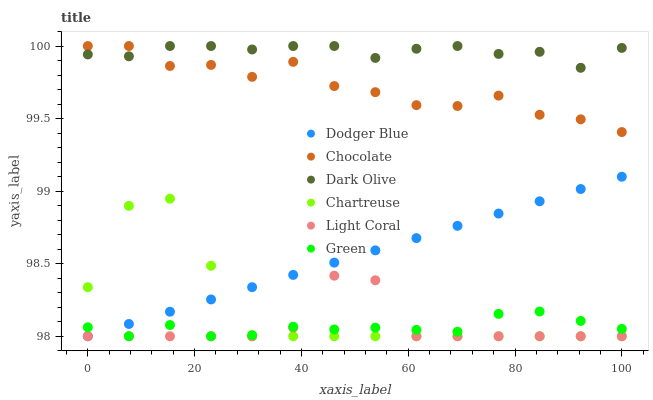Does Green have the minimum area under the curve?
Answer yes or no. Yes. Does Dark Olive have the maximum area under the curve?
Answer yes or no. Yes. Does Chocolate have the minimum area under the curve?
Answer yes or no. No. Does Chocolate have the maximum area under the curve?
Answer yes or no. No. Is Dodger Blue the smoothest?
Answer yes or no. Yes. Is Chartreuse the roughest?
Answer yes or no. Yes. Is Chocolate the smoothest?
Answer yes or no. No. Is Chocolate the roughest?
Answer yes or no. No. Does Light Coral have the lowest value?
Answer yes or no. Yes. Does Chocolate have the lowest value?
Answer yes or no. No. Does Chocolate have the highest value?
Answer yes or no. Yes. Does Light Coral have the highest value?
Answer yes or no. No. Is Green less than Chocolate?
Answer yes or no. Yes. Is Chocolate greater than Green?
Answer yes or no. Yes. Does Dodger Blue intersect Green?
Answer yes or no. Yes. Is Dodger Blue less than Green?
Answer yes or no. No. Is Dodger Blue greater than Green?
Answer yes or no. No. Does Green intersect Chocolate?
Answer yes or no. No. 